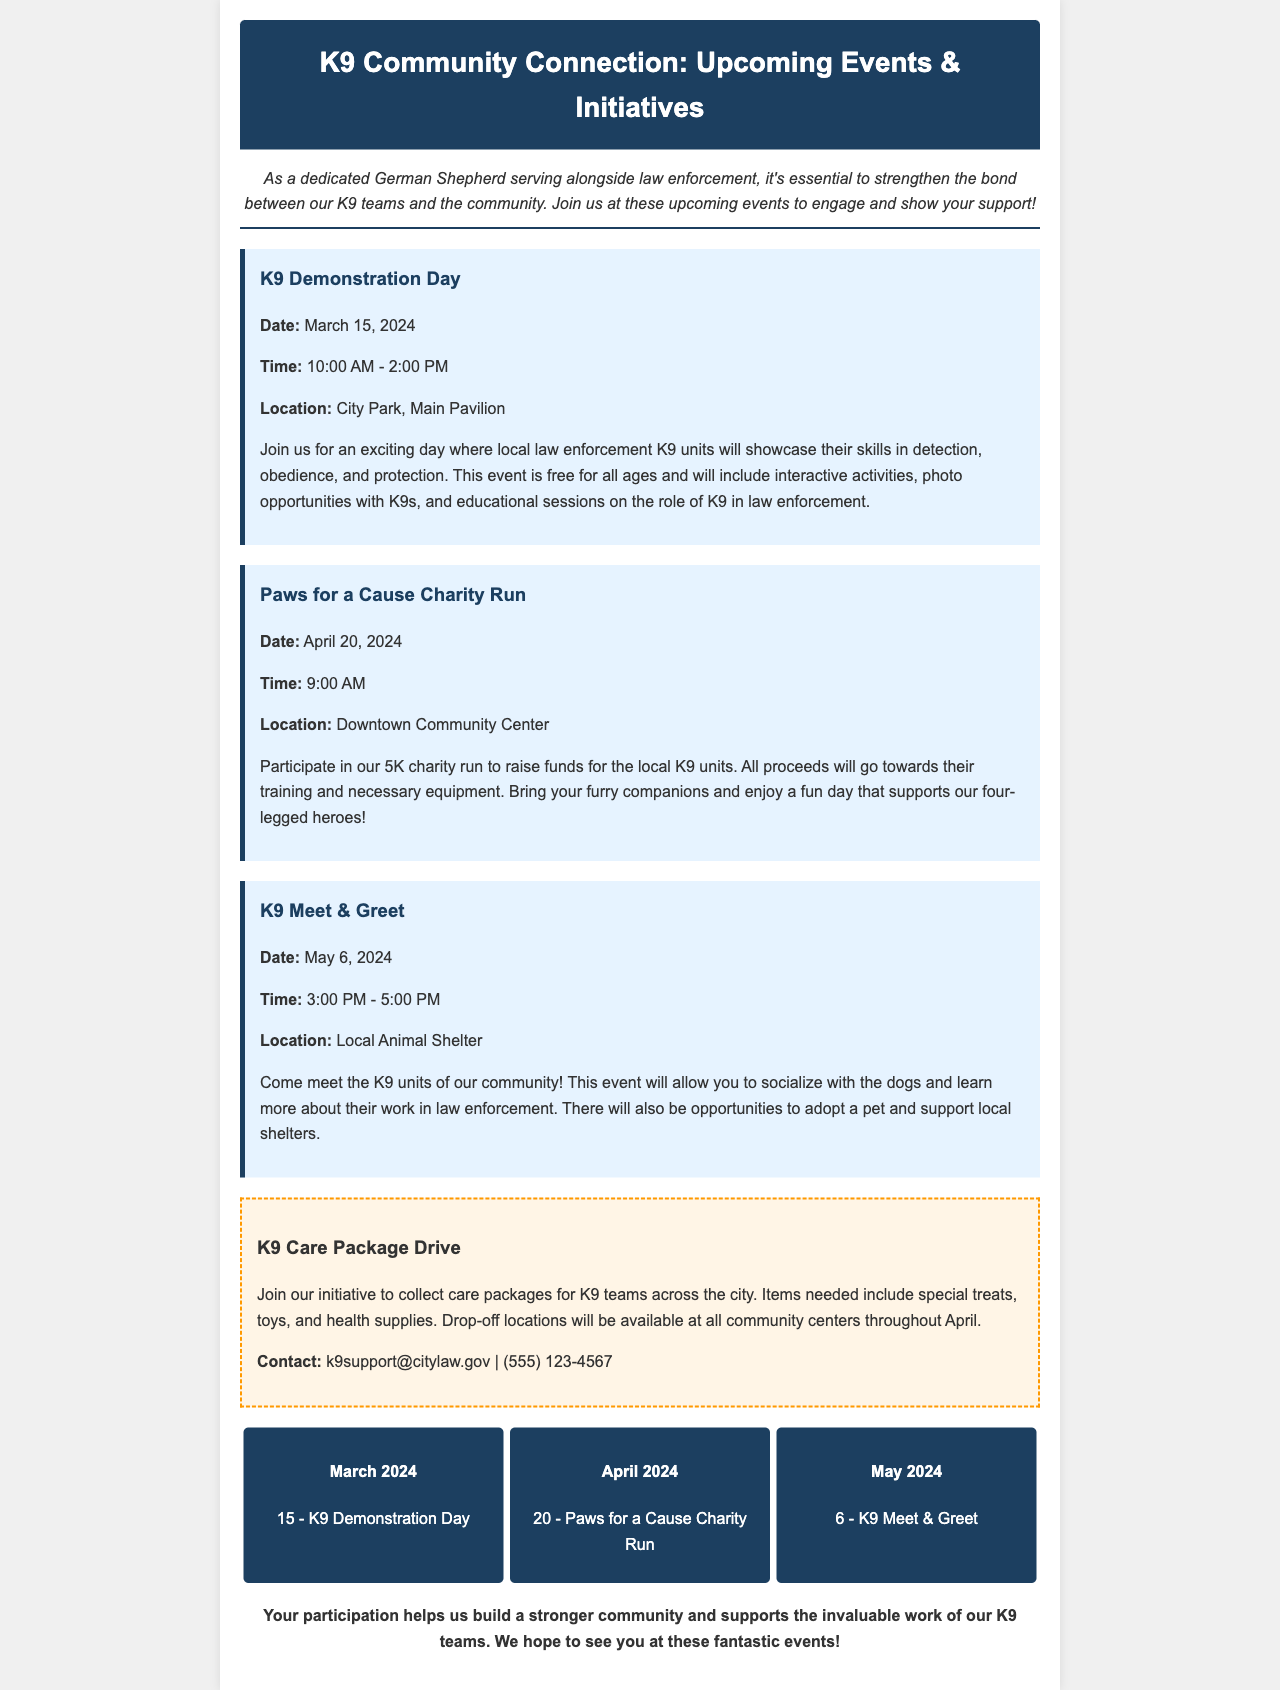What is the date of the K9 Demonstration Day? The date for the K9 Demonstration Day is mentioned in the event section of the document, which is March 15, 2024.
Answer: March 15, 2024 What time does the Paws for a Cause Charity Run start? The start time for the Paws for a Cause Charity Run is specified in the details of the event, which is 9:00 AM.
Answer: 9:00 AM Where is the K9 Meet & Greet being held? The location for the K9 Meet & Greet is listed in the event details, which is at the Local Animal Shelter.
Answer: Local Animal Shelter What items are needed for the K9 Care Package Drive? The items needed for the K9 Care Package Drive are specified to include treats, toys, and health supplies.
Answer: Treats, toys, and health supplies Which month features the K9 Demonstration Day on the calendar? The calendar section shows that the K9 Demonstration Day occurs in March 2024.
Answer: March 2024 What is the purpose of the Paws for a Cause Charity Run? The purpose of the Paws for a Cause Charity Run is explained to raise funds for the local K9 units.
Answer: Raise funds for local K9 units What activities will be present at the K9 Demonstration Day? The K9 Demonstration Day will include activities such as detection, obedience, and protection demonstrations.
Answer: Detection, obedience, and protection What is the main focus of the newsletter? The main focus of the newsletter is to engage the community with upcoming events and support for local law enforcement K9 teams.
Answer: Engage the community with upcoming events 